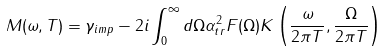Convert formula to latex. <formula><loc_0><loc_0><loc_500><loc_500>M ( \omega , T ) = \gamma _ { i m p } - 2 i \int _ { 0 } ^ { \infty } d \Omega \alpha ^ { 2 } _ { t r } F ( \Omega ) K \left ( \frac { \omega } { 2 \pi T } , \frac { \Omega } { 2 \pi T } \right )</formula> 